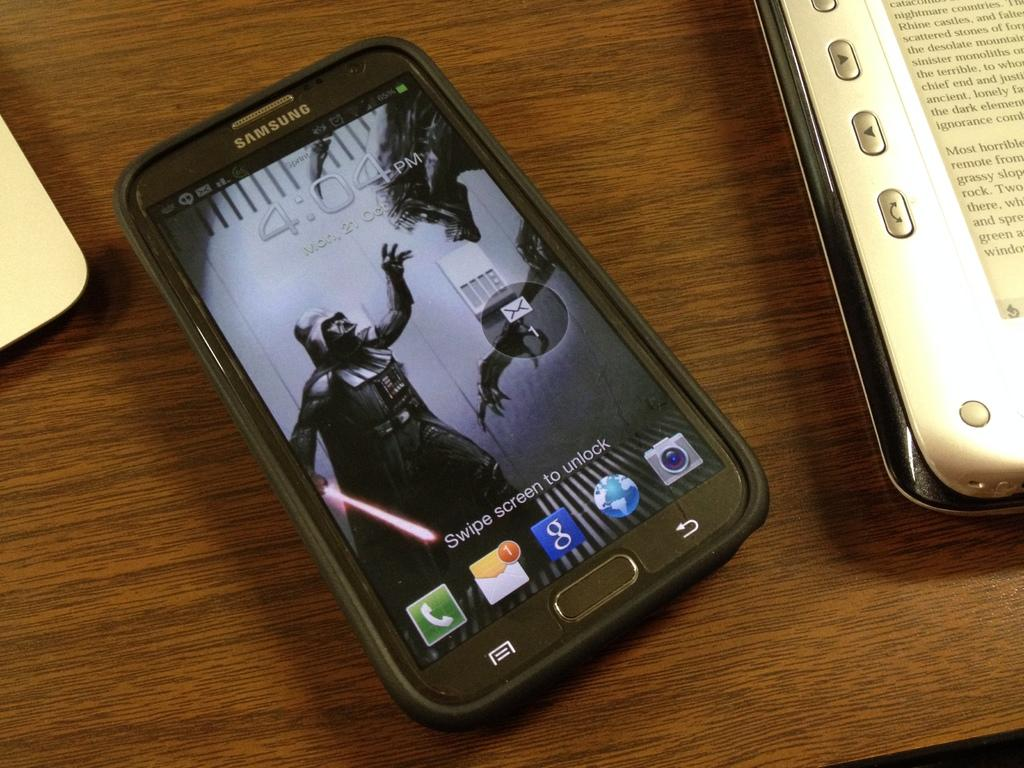<image>
Share a concise interpretation of the image provided. The Samsung smartphone has a screensaver of Darth Vader from Star wars. 